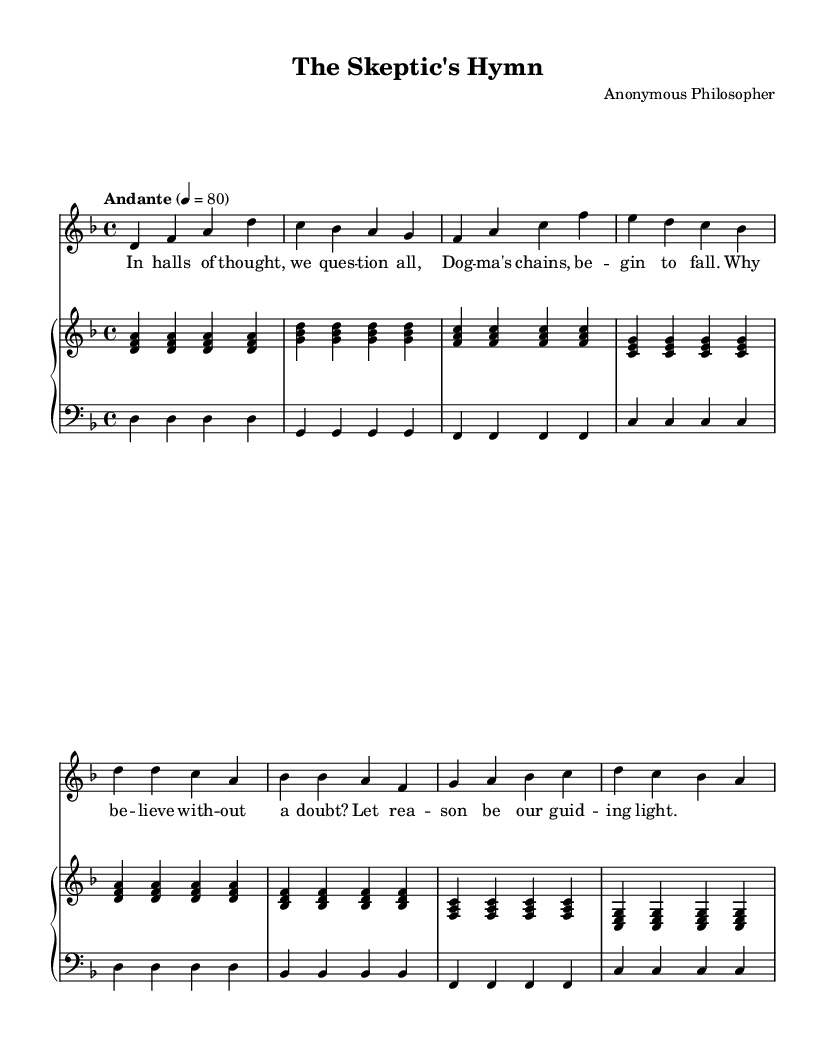What is the key signature of this piece? The key signature is indicated at the beginning of the staff; it shows two flats, indicating that the key is B flat major or G minor.
Answer: B flat What is the time signature of the piece? The time signature is found at the beginning of the sheet music, represented by the "4/4" notation, which means there are four beats per measure and the quarter note gets one beat.
Answer: 4/4 What is the tempo marking for this piece? The tempo marking is displayed above the staff in Italian, indicating the speed at which the piece should be played; "Andante" means a moderate walking pace.
Answer: Andante How many measures are in the chorus? To determine the number of measures in the chorus, we count the bars in the chorus section, which is separate from the verse; there are 4 measures in the chorus.
Answer: 4 What is the form of the hymn based on the provided structure? By analysing the structure, we see that it follows a verse-chorus form; it alternates between verses and choruses, which is typical for hymns.
Answer: Verse-Chorus What is the mood conveyed by the lyrics of the hymn? The lyrics of the hymn reflect a questioning and reflective mood, indicating discontent with traditional beliefs and advocating for the use of reason, which may indicate a more contemplative or even critical tone.
Answer: Reflective 